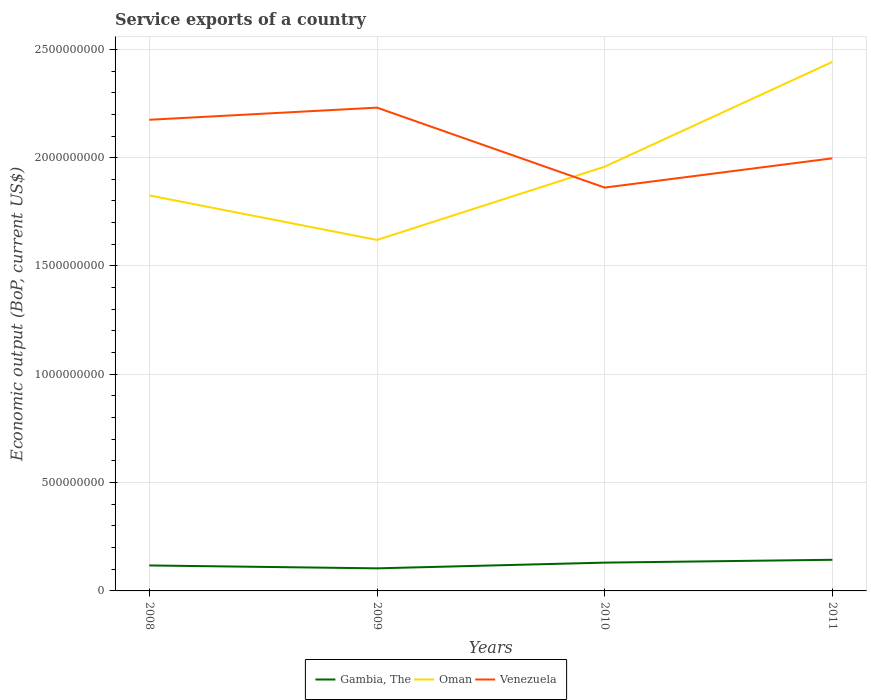How many different coloured lines are there?
Give a very brief answer. 3. Does the line corresponding to Venezuela intersect with the line corresponding to Oman?
Offer a very short reply. Yes. Is the number of lines equal to the number of legend labels?
Make the answer very short. Yes. Across all years, what is the maximum service exports in Gambia, The?
Keep it short and to the point. 1.04e+08. What is the total service exports in Gambia, The in the graph?
Provide a short and direct response. -1.31e+07. What is the difference between the highest and the second highest service exports in Gambia, The?
Your answer should be very brief. 3.95e+07. Where does the legend appear in the graph?
Ensure brevity in your answer.  Bottom center. How many legend labels are there?
Provide a short and direct response. 3. How are the legend labels stacked?
Make the answer very short. Horizontal. What is the title of the graph?
Keep it short and to the point. Service exports of a country. Does "Congo (Democratic)" appear as one of the legend labels in the graph?
Ensure brevity in your answer.  No. What is the label or title of the X-axis?
Make the answer very short. Years. What is the label or title of the Y-axis?
Give a very brief answer. Economic output (BoP, current US$). What is the Economic output (BoP, current US$) in Gambia, The in 2008?
Provide a short and direct response. 1.18e+08. What is the Economic output (BoP, current US$) of Oman in 2008?
Provide a short and direct response. 1.83e+09. What is the Economic output (BoP, current US$) in Venezuela in 2008?
Make the answer very short. 2.18e+09. What is the Economic output (BoP, current US$) in Gambia, The in 2009?
Make the answer very short. 1.04e+08. What is the Economic output (BoP, current US$) of Oman in 2009?
Your answer should be compact. 1.62e+09. What is the Economic output (BoP, current US$) in Venezuela in 2009?
Ensure brevity in your answer.  2.23e+09. What is the Economic output (BoP, current US$) in Gambia, The in 2010?
Ensure brevity in your answer.  1.31e+08. What is the Economic output (BoP, current US$) in Oman in 2010?
Your answer should be compact. 1.96e+09. What is the Economic output (BoP, current US$) of Venezuela in 2010?
Offer a terse response. 1.86e+09. What is the Economic output (BoP, current US$) of Gambia, The in 2011?
Make the answer very short. 1.44e+08. What is the Economic output (BoP, current US$) of Oman in 2011?
Provide a short and direct response. 2.44e+09. What is the Economic output (BoP, current US$) in Venezuela in 2011?
Provide a short and direct response. 2.00e+09. Across all years, what is the maximum Economic output (BoP, current US$) of Gambia, The?
Make the answer very short. 1.44e+08. Across all years, what is the maximum Economic output (BoP, current US$) in Oman?
Provide a succinct answer. 2.44e+09. Across all years, what is the maximum Economic output (BoP, current US$) of Venezuela?
Offer a terse response. 2.23e+09. Across all years, what is the minimum Economic output (BoP, current US$) in Gambia, The?
Offer a very short reply. 1.04e+08. Across all years, what is the minimum Economic output (BoP, current US$) of Oman?
Your response must be concise. 1.62e+09. Across all years, what is the minimum Economic output (BoP, current US$) of Venezuela?
Offer a terse response. 1.86e+09. What is the total Economic output (BoP, current US$) of Gambia, The in the graph?
Your answer should be very brief. 4.96e+08. What is the total Economic output (BoP, current US$) of Oman in the graph?
Keep it short and to the point. 7.85e+09. What is the total Economic output (BoP, current US$) of Venezuela in the graph?
Offer a very short reply. 8.26e+09. What is the difference between the Economic output (BoP, current US$) of Gambia, The in 2008 and that in 2009?
Provide a short and direct response. 1.34e+07. What is the difference between the Economic output (BoP, current US$) of Oman in 2008 and that in 2009?
Give a very brief answer. 2.05e+08. What is the difference between the Economic output (BoP, current US$) of Venezuela in 2008 and that in 2009?
Your response must be concise. -5.60e+07. What is the difference between the Economic output (BoP, current US$) of Gambia, The in 2008 and that in 2010?
Keep it short and to the point. -1.31e+07. What is the difference between the Economic output (BoP, current US$) of Oman in 2008 and that in 2010?
Offer a terse response. -1.33e+08. What is the difference between the Economic output (BoP, current US$) of Venezuela in 2008 and that in 2010?
Provide a short and direct response. 3.13e+08. What is the difference between the Economic output (BoP, current US$) of Gambia, The in 2008 and that in 2011?
Your response must be concise. -2.62e+07. What is the difference between the Economic output (BoP, current US$) of Oman in 2008 and that in 2011?
Offer a very short reply. -6.16e+08. What is the difference between the Economic output (BoP, current US$) of Venezuela in 2008 and that in 2011?
Give a very brief answer. 1.78e+08. What is the difference between the Economic output (BoP, current US$) in Gambia, The in 2009 and that in 2010?
Offer a very short reply. -2.65e+07. What is the difference between the Economic output (BoP, current US$) in Oman in 2009 and that in 2010?
Offer a very short reply. -3.38e+08. What is the difference between the Economic output (BoP, current US$) of Venezuela in 2009 and that in 2010?
Your response must be concise. 3.69e+08. What is the difference between the Economic output (BoP, current US$) in Gambia, The in 2009 and that in 2011?
Offer a very short reply. -3.95e+07. What is the difference between the Economic output (BoP, current US$) of Oman in 2009 and that in 2011?
Ensure brevity in your answer.  -8.22e+08. What is the difference between the Economic output (BoP, current US$) in Venezuela in 2009 and that in 2011?
Your response must be concise. 2.34e+08. What is the difference between the Economic output (BoP, current US$) in Gambia, The in 2010 and that in 2011?
Offer a terse response. -1.31e+07. What is the difference between the Economic output (BoP, current US$) in Oman in 2010 and that in 2011?
Offer a very short reply. -4.84e+08. What is the difference between the Economic output (BoP, current US$) of Venezuela in 2010 and that in 2011?
Your answer should be very brief. -1.35e+08. What is the difference between the Economic output (BoP, current US$) of Gambia, The in 2008 and the Economic output (BoP, current US$) of Oman in 2009?
Offer a terse response. -1.50e+09. What is the difference between the Economic output (BoP, current US$) in Gambia, The in 2008 and the Economic output (BoP, current US$) in Venezuela in 2009?
Provide a short and direct response. -2.11e+09. What is the difference between the Economic output (BoP, current US$) of Oman in 2008 and the Economic output (BoP, current US$) of Venezuela in 2009?
Your answer should be compact. -4.05e+08. What is the difference between the Economic output (BoP, current US$) of Gambia, The in 2008 and the Economic output (BoP, current US$) of Oman in 2010?
Ensure brevity in your answer.  -1.84e+09. What is the difference between the Economic output (BoP, current US$) in Gambia, The in 2008 and the Economic output (BoP, current US$) in Venezuela in 2010?
Provide a short and direct response. -1.74e+09. What is the difference between the Economic output (BoP, current US$) in Oman in 2008 and the Economic output (BoP, current US$) in Venezuela in 2010?
Keep it short and to the point. -3.63e+07. What is the difference between the Economic output (BoP, current US$) in Gambia, The in 2008 and the Economic output (BoP, current US$) in Oman in 2011?
Your answer should be very brief. -2.32e+09. What is the difference between the Economic output (BoP, current US$) of Gambia, The in 2008 and the Economic output (BoP, current US$) of Venezuela in 2011?
Your answer should be very brief. -1.88e+09. What is the difference between the Economic output (BoP, current US$) of Oman in 2008 and the Economic output (BoP, current US$) of Venezuela in 2011?
Keep it short and to the point. -1.71e+08. What is the difference between the Economic output (BoP, current US$) of Gambia, The in 2009 and the Economic output (BoP, current US$) of Oman in 2010?
Your answer should be very brief. -1.85e+09. What is the difference between the Economic output (BoP, current US$) of Gambia, The in 2009 and the Economic output (BoP, current US$) of Venezuela in 2010?
Your response must be concise. -1.76e+09. What is the difference between the Economic output (BoP, current US$) in Oman in 2009 and the Economic output (BoP, current US$) in Venezuela in 2010?
Give a very brief answer. -2.42e+08. What is the difference between the Economic output (BoP, current US$) of Gambia, The in 2009 and the Economic output (BoP, current US$) of Oman in 2011?
Keep it short and to the point. -2.34e+09. What is the difference between the Economic output (BoP, current US$) of Gambia, The in 2009 and the Economic output (BoP, current US$) of Venezuela in 2011?
Ensure brevity in your answer.  -1.89e+09. What is the difference between the Economic output (BoP, current US$) of Oman in 2009 and the Economic output (BoP, current US$) of Venezuela in 2011?
Keep it short and to the point. -3.77e+08. What is the difference between the Economic output (BoP, current US$) of Gambia, The in 2010 and the Economic output (BoP, current US$) of Oman in 2011?
Your answer should be compact. -2.31e+09. What is the difference between the Economic output (BoP, current US$) of Gambia, The in 2010 and the Economic output (BoP, current US$) of Venezuela in 2011?
Make the answer very short. -1.87e+09. What is the difference between the Economic output (BoP, current US$) in Oman in 2010 and the Economic output (BoP, current US$) in Venezuela in 2011?
Make the answer very short. -3.86e+07. What is the average Economic output (BoP, current US$) in Gambia, The per year?
Offer a terse response. 1.24e+08. What is the average Economic output (BoP, current US$) of Oman per year?
Your response must be concise. 1.96e+09. What is the average Economic output (BoP, current US$) in Venezuela per year?
Provide a succinct answer. 2.07e+09. In the year 2008, what is the difference between the Economic output (BoP, current US$) in Gambia, The and Economic output (BoP, current US$) in Oman?
Give a very brief answer. -1.71e+09. In the year 2008, what is the difference between the Economic output (BoP, current US$) in Gambia, The and Economic output (BoP, current US$) in Venezuela?
Your answer should be compact. -2.06e+09. In the year 2008, what is the difference between the Economic output (BoP, current US$) in Oman and Economic output (BoP, current US$) in Venezuela?
Give a very brief answer. -3.49e+08. In the year 2009, what is the difference between the Economic output (BoP, current US$) of Gambia, The and Economic output (BoP, current US$) of Oman?
Keep it short and to the point. -1.52e+09. In the year 2009, what is the difference between the Economic output (BoP, current US$) of Gambia, The and Economic output (BoP, current US$) of Venezuela?
Ensure brevity in your answer.  -2.13e+09. In the year 2009, what is the difference between the Economic output (BoP, current US$) in Oman and Economic output (BoP, current US$) in Venezuela?
Provide a short and direct response. -6.11e+08. In the year 2010, what is the difference between the Economic output (BoP, current US$) in Gambia, The and Economic output (BoP, current US$) in Oman?
Your answer should be compact. -1.83e+09. In the year 2010, what is the difference between the Economic output (BoP, current US$) in Gambia, The and Economic output (BoP, current US$) in Venezuela?
Provide a succinct answer. -1.73e+09. In the year 2010, what is the difference between the Economic output (BoP, current US$) in Oman and Economic output (BoP, current US$) in Venezuela?
Your answer should be compact. 9.64e+07. In the year 2011, what is the difference between the Economic output (BoP, current US$) of Gambia, The and Economic output (BoP, current US$) of Oman?
Your answer should be compact. -2.30e+09. In the year 2011, what is the difference between the Economic output (BoP, current US$) in Gambia, The and Economic output (BoP, current US$) in Venezuela?
Keep it short and to the point. -1.85e+09. In the year 2011, what is the difference between the Economic output (BoP, current US$) of Oman and Economic output (BoP, current US$) of Venezuela?
Your response must be concise. 4.45e+08. What is the ratio of the Economic output (BoP, current US$) in Gambia, The in 2008 to that in 2009?
Give a very brief answer. 1.13. What is the ratio of the Economic output (BoP, current US$) of Oman in 2008 to that in 2009?
Provide a short and direct response. 1.13. What is the ratio of the Economic output (BoP, current US$) of Venezuela in 2008 to that in 2009?
Offer a very short reply. 0.97. What is the ratio of the Economic output (BoP, current US$) of Oman in 2008 to that in 2010?
Your answer should be compact. 0.93. What is the ratio of the Economic output (BoP, current US$) in Venezuela in 2008 to that in 2010?
Offer a terse response. 1.17. What is the ratio of the Economic output (BoP, current US$) of Gambia, The in 2008 to that in 2011?
Ensure brevity in your answer.  0.82. What is the ratio of the Economic output (BoP, current US$) of Oman in 2008 to that in 2011?
Keep it short and to the point. 0.75. What is the ratio of the Economic output (BoP, current US$) in Venezuela in 2008 to that in 2011?
Offer a terse response. 1.09. What is the ratio of the Economic output (BoP, current US$) in Gambia, The in 2009 to that in 2010?
Your answer should be very brief. 0.8. What is the ratio of the Economic output (BoP, current US$) of Oman in 2009 to that in 2010?
Offer a very short reply. 0.83. What is the ratio of the Economic output (BoP, current US$) of Venezuela in 2009 to that in 2010?
Make the answer very short. 1.2. What is the ratio of the Economic output (BoP, current US$) of Gambia, The in 2009 to that in 2011?
Give a very brief answer. 0.72. What is the ratio of the Economic output (BoP, current US$) of Oman in 2009 to that in 2011?
Keep it short and to the point. 0.66. What is the ratio of the Economic output (BoP, current US$) of Venezuela in 2009 to that in 2011?
Offer a terse response. 1.12. What is the ratio of the Economic output (BoP, current US$) of Gambia, The in 2010 to that in 2011?
Offer a terse response. 0.91. What is the ratio of the Economic output (BoP, current US$) of Oman in 2010 to that in 2011?
Make the answer very short. 0.8. What is the ratio of the Economic output (BoP, current US$) in Venezuela in 2010 to that in 2011?
Ensure brevity in your answer.  0.93. What is the difference between the highest and the second highest Economic output (BoP, current US$) of Gambia, The?
Your response must be concise. 1.31e+07. What is the difference between the highest and the second highest Economic output (BoP, current US$) of Oman?
Make the answer very short. 4.84e+08. What is the difference between the highest and the second highest Economic output (BoP, current US$) in Venezuela?
Offer a very short reply. 5.60e+07. What is the difference between the highest and the lowest Economic output (BoP, current US$) of Gambia, The?
Provide a succinct answer. 3.95e+07. What is the difference between the highest and the lowest Economic output (BoP, current US$) of Oman?
Provide a short and direct response. 8.22e+08. What is the difference between the highest and the lowest Economic output (BoP, current US$) in Venezuela?
Offer a terse response. 3.69e+08. 